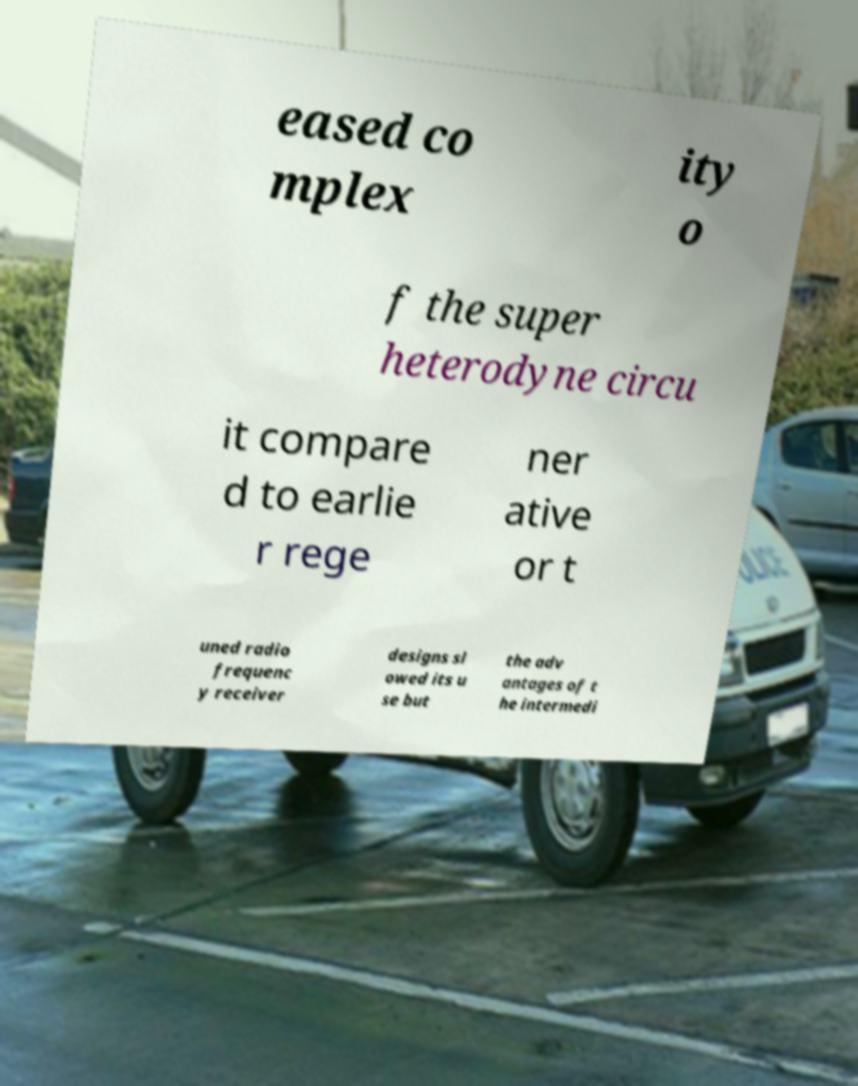I need the written content from this picture converted into text. Can you do that? eased co mplex ity o f the super heterodyne circu it compare d to earlie r rege ner ative or t uned radio frequenc y receiver designs sl owed its u se but the adv antages of t he intermedi 